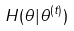<formula> <loc_0><loc_0><loc_500><loc_500>H ( \theta | \theta ^ { ( t ) } )</formula> 